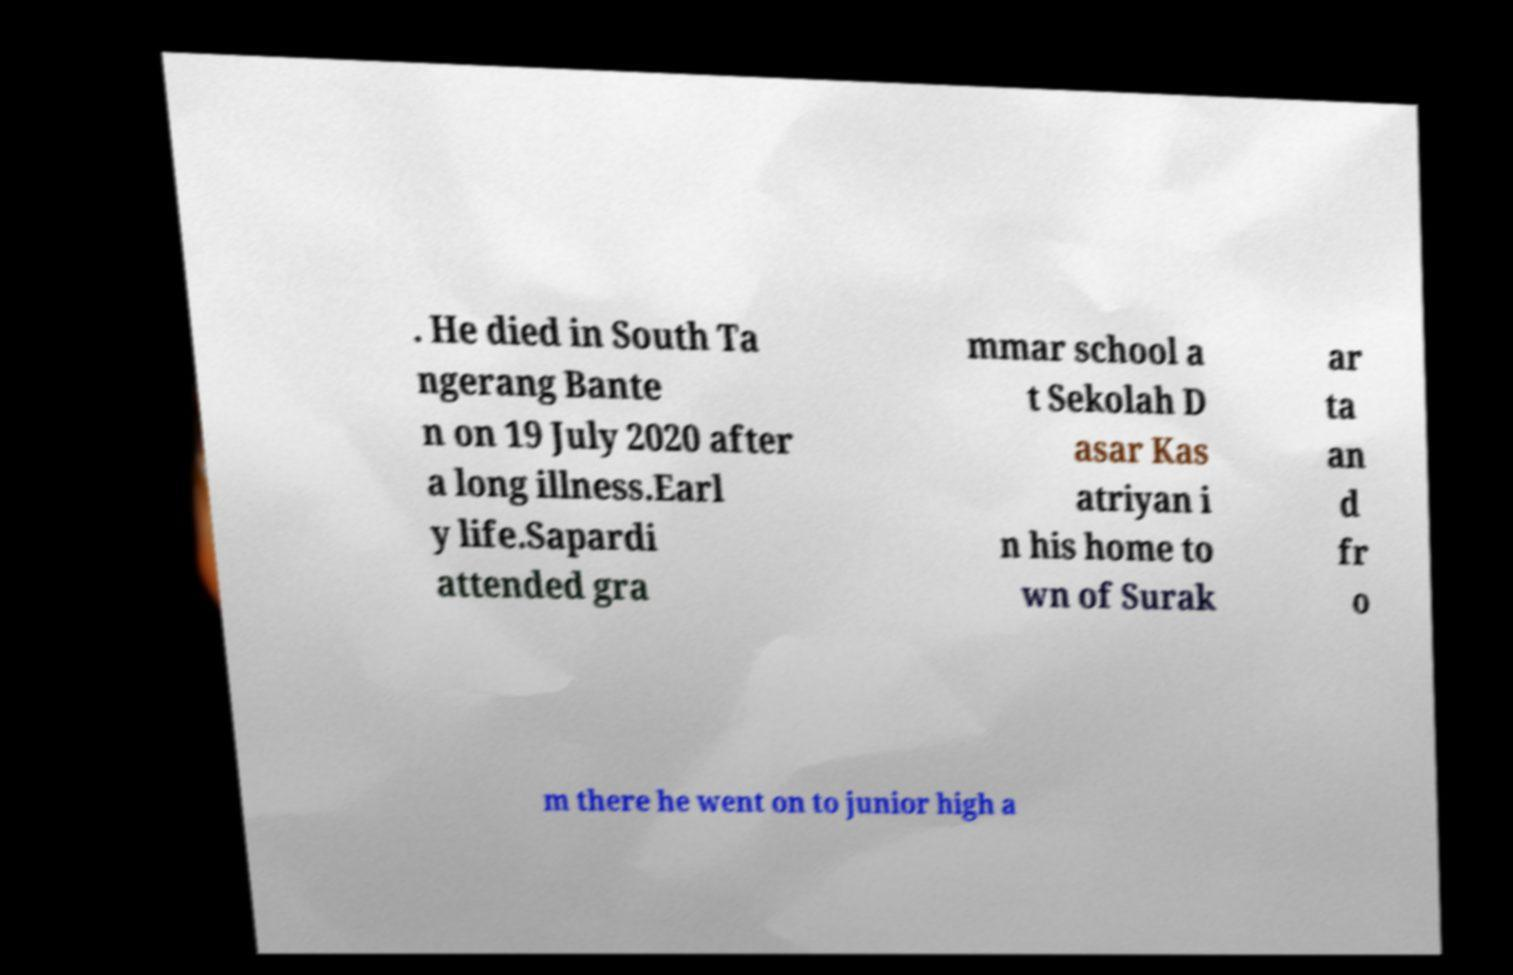What messages or text are displayed in this image? I need them in a readable, typed format. . He died in South Ta ngerang Bante n on 19 July 2020 after a long illness.Earl y life.Sapardi attended gra mmar school a t Sekolah D asar Kas atriyan i n his home to wn of Surak ar ta an d fr o m there he went on to junior high a 